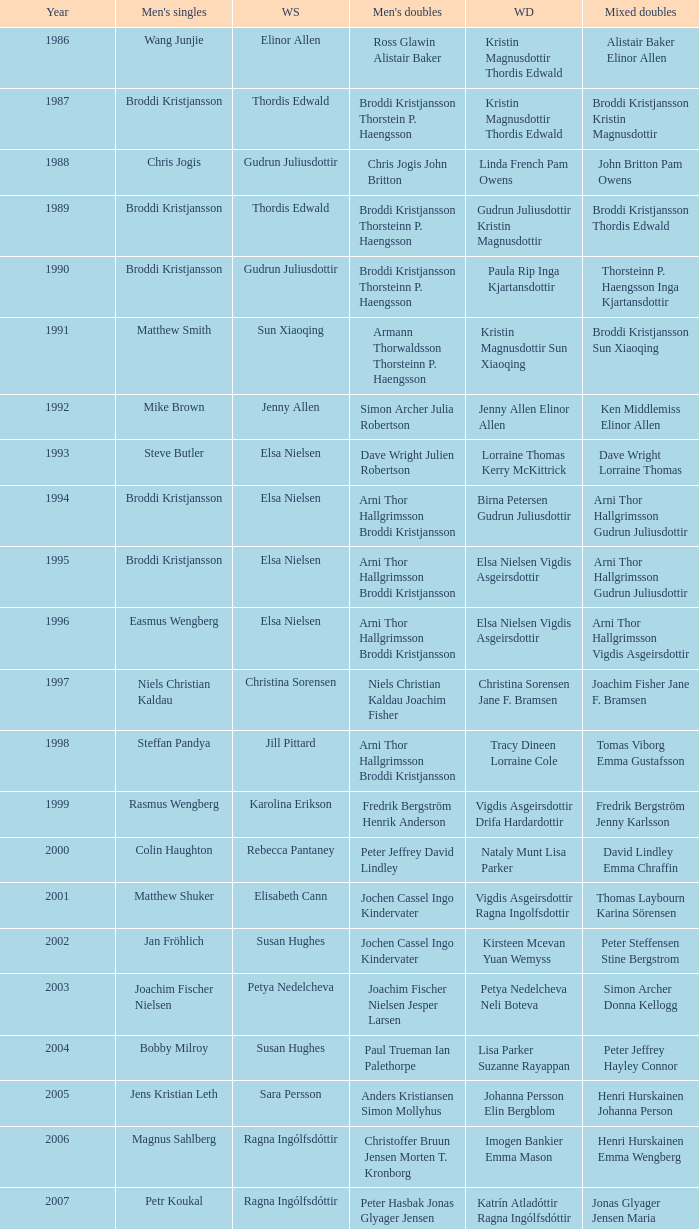In which women's doubles did Wang Junjie play men's singles? Kristin Magnusdottir Thordis Edwald. 